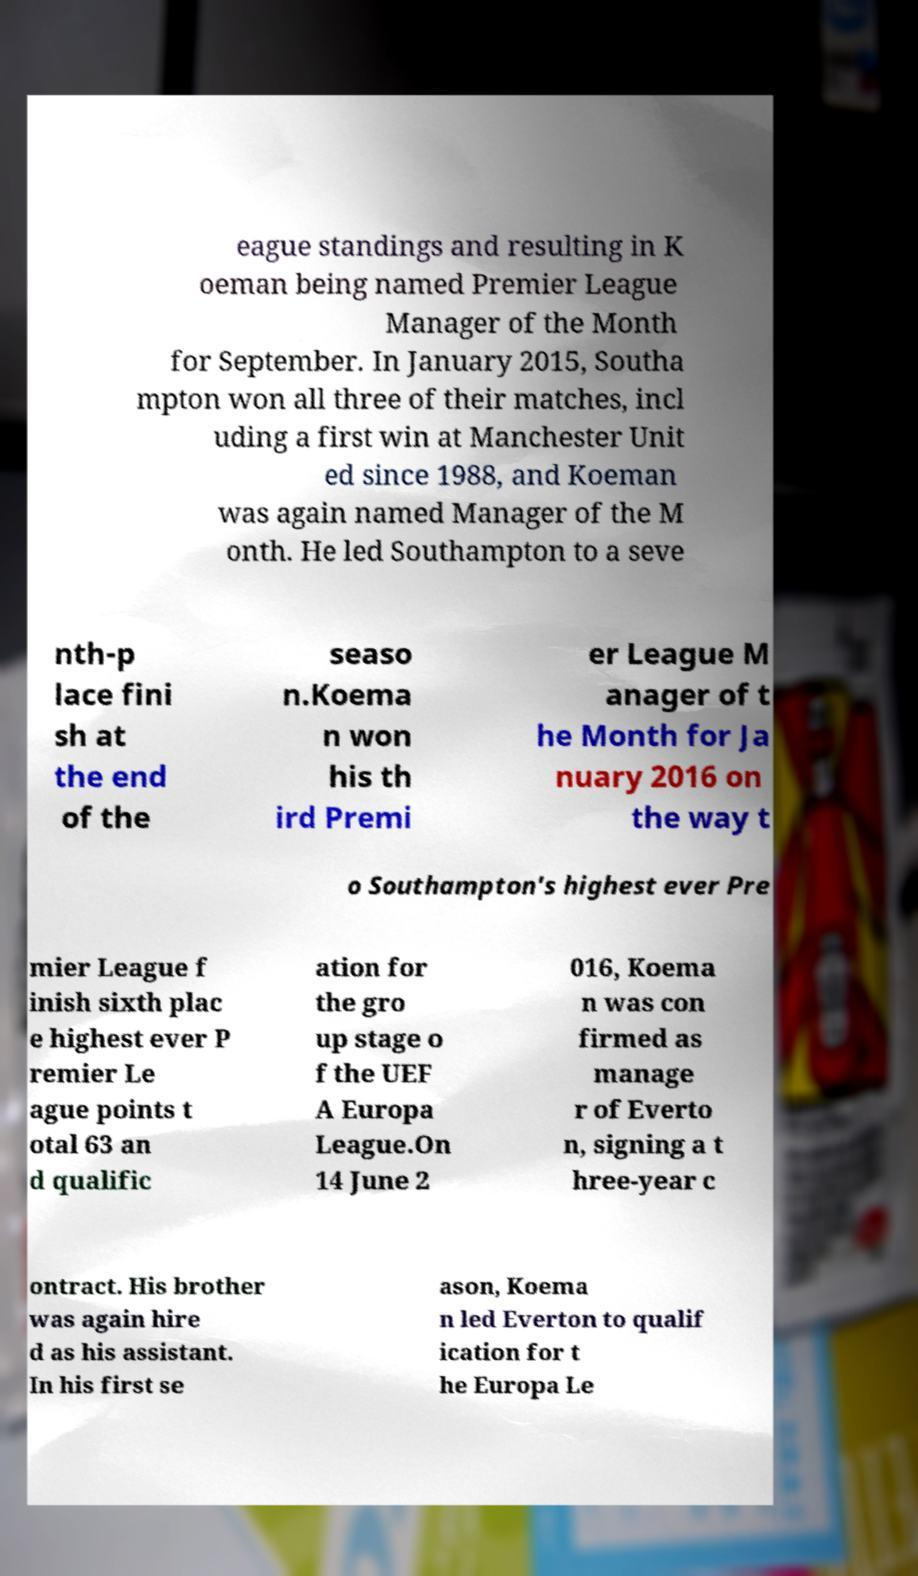I need the written content from this picture converted into text. Can you do that? eague standings and resulting in K oeman being named Premier League Manager of the Month for September. In January 2015, Southa mpton won all three of their matches, incl uding a first win at Manchester Unit ed since 1988, and Koeman was again named Manager of the M onth. He led Southampton to a seve nth-p lace fini sh at the end of the seaso n.Koema n won his th ird Premi er League M anager of t he Month for Ja nuary 2016 on the way t o Southampton's highest ever Pre mier League f inish sixth plac e highest ever P remier Le ague points t otal 63 an d qualific ation for the gro up stage o f the UEF A Europa League.On 14 June 2 016, Koema n was con firmed as manage r of Everto n, signing a t hree-year c ontract. His brother was again hire d as his assistant. In his first se ason, Koema n led Everton to qualif ication for t he Europa Le 